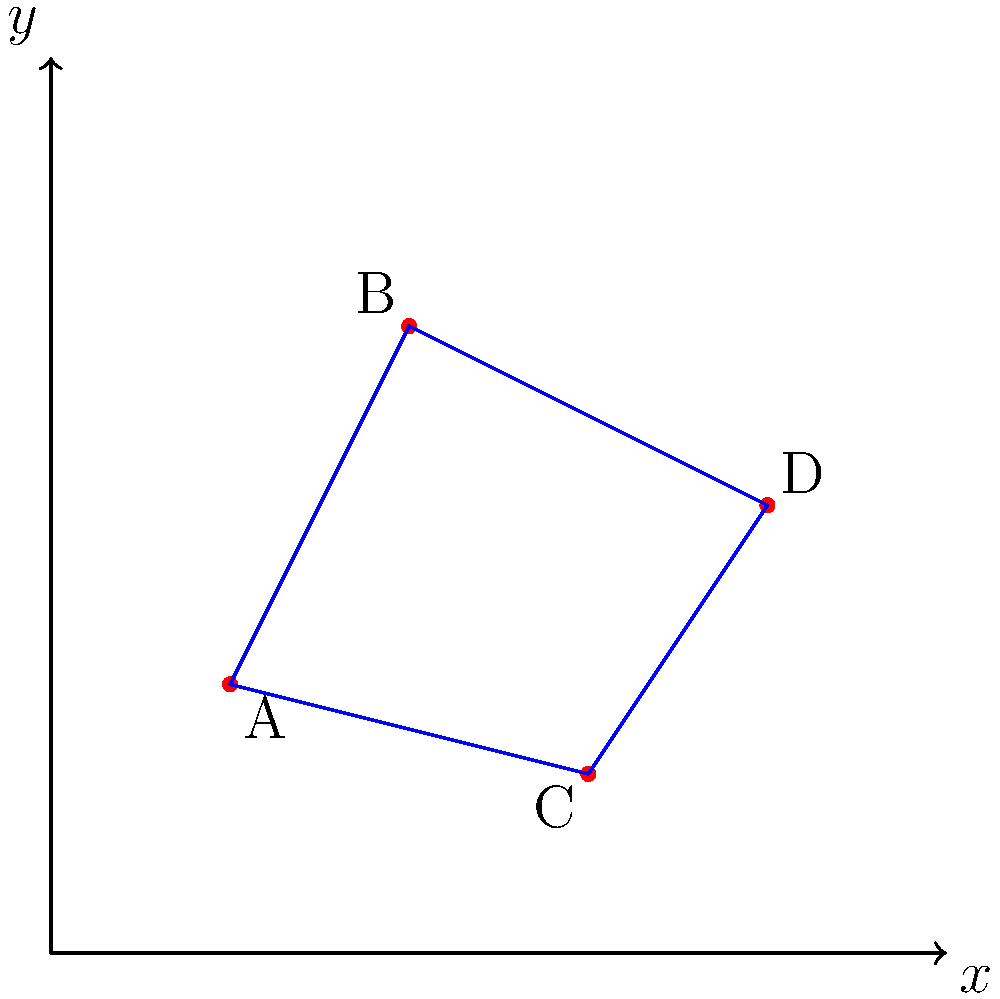During an excavation in Scotland, you've uncovered four prehistoric artifacts at locations A(2,3), B(4,7), C(6,2), and D(8,5) on a coordinate plane. You suspect these artifacts might outline a habitat of a mythical creature. If you connect these points to form a polygon, what is the area of the potential habitat in square units? To find the area of the polygon formed by the artifact locations, we can use the Shoelace formula (also known as the surveyor's formula). The steps are as follows:

1) First, let's organize our points in clockwise or counterclockwise order:
   A(2,3), B(4,7), D(8,5), C(6,2)

2) The Shoelace formula for a quadrilateral is:
   $$Area = \frac{1}{2}|(x_1y_2 + x_2y_3 + x_3y_4 + x_4y_1) - (y_1x_2 + y_2x_3 + y_3x_4 + y_4x_1)|$$

3) Let's substitute our values:
   $$Area = \frac{1}{2}|(2 \cdot 7 + 4 \cdot 5 + 8 \cdot 2 + 6 \cdot 3) - (3 \cdot 4 + 7 \cdot 8 + 5 \cdot 6 + 2 \cdot 2)|$$

4) Calculate the values inside the parentheses:
   $$Area = \frac{1}{2}|(14 + 20 + 16 + 18) - (12 + 56 + 30 + 4)|$$

5) Simplify:
   $$Area = \frac{1}{2}|68 - 102|$$
   $$Area = \frac{1}{2}|-34|$$
   $$Area = \frac{1}{2}(34)$$

6) Calculate the final result:
   $$Area = 17$$

Therefore, the area of the potential mythical creature habitat is 17 square units.
Answer: 17 square units 